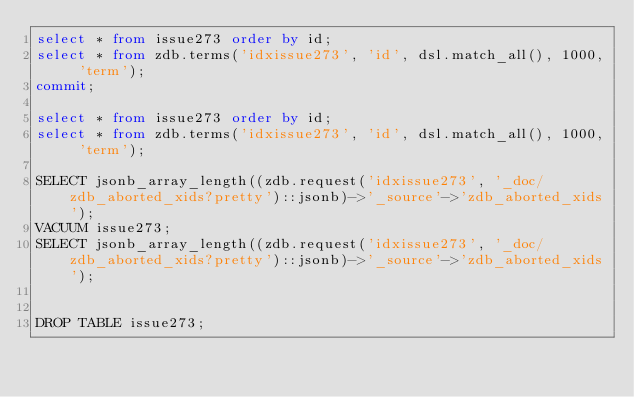Convert code to text. <code><loc_0><loc_0><loc_500><loc_500><_SQL_>select * from issue273 order by id;
select * from zdb.terms('idxissue273', 'id', dsl.match_all(), 1000, 'term');
commit;

select * from issue273 order by id;
select * from zdb.terms('idxissue273', 'id', dsl.match_all(), 1000, 'term');

SELECT jsonb_array_length((zdb.request('idxissue273', '_doc/zdb_aborted_xids?pretty')::jsonb)->'_source'->'zdb_aborted_xids');
VACUUM issue273;
SELECT jsonb_array_length((zdb.request('idxissue273', '_doc/zdb_aborted_xids?pretty')::jsonb)->'_source'->'zdb_aborted_xids');


DROP TABLE issue273;
</code> 